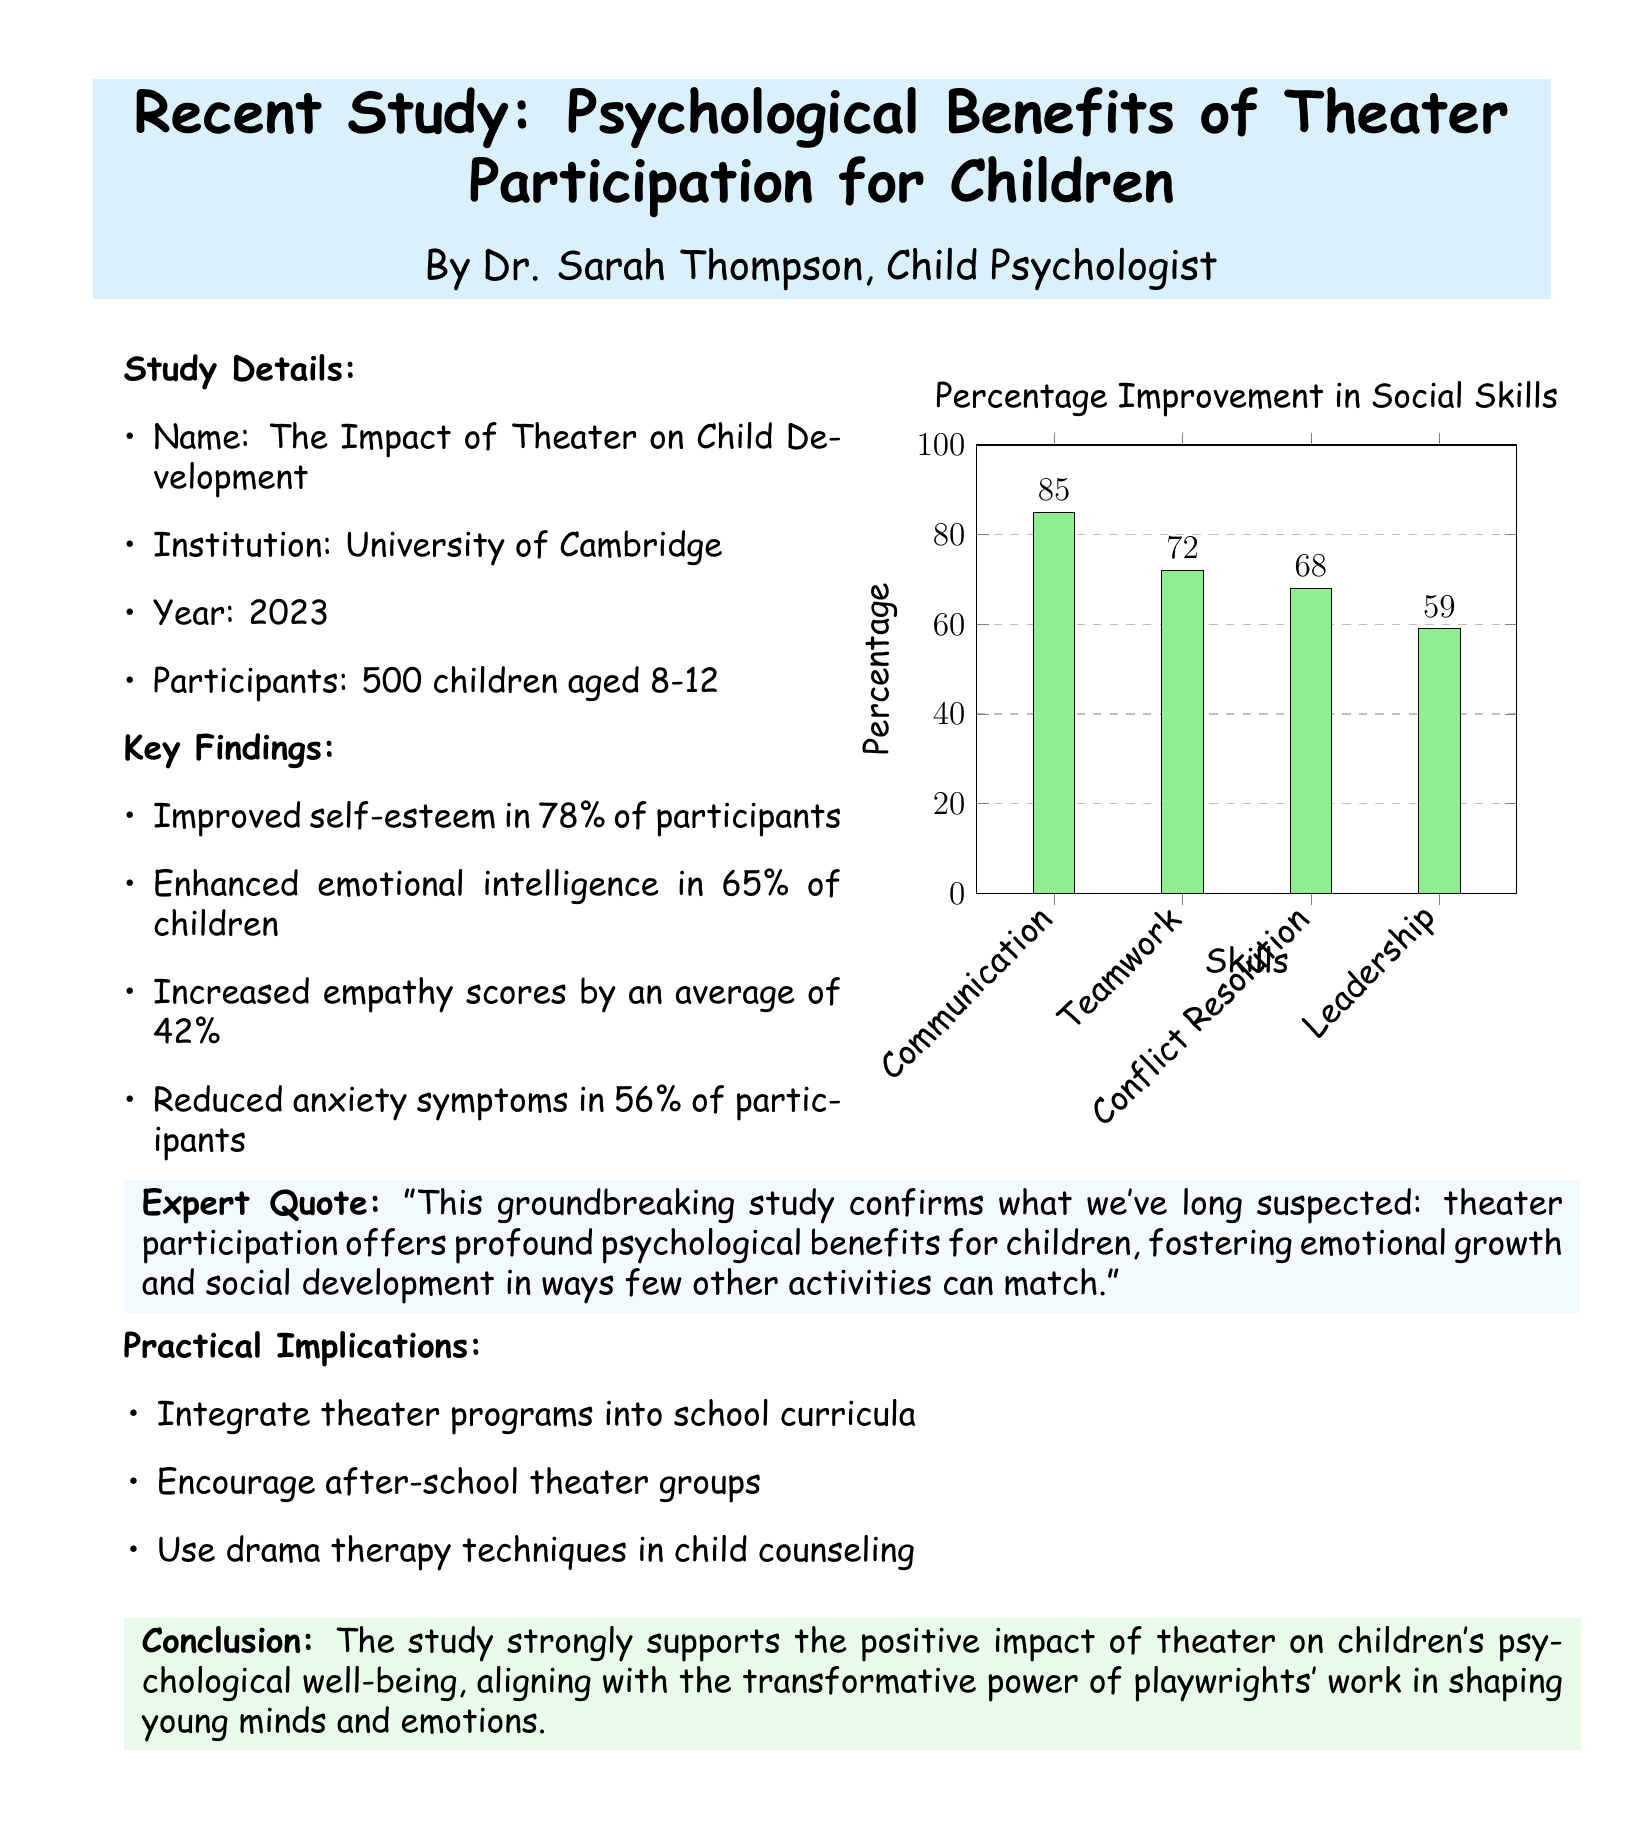What is the name of the study? The document mentions "The Impact of Theater on Child Development" as the name of the study.
Answer: The Impact of Theater on Child Development What year was the study conducted? According to the document, the study was conducted in 2023.
Answer: 2023 How many children participated in the study? The document states that there were 500 children involved in the study.
Answer: 500 What percentage of participants improved their self-esteem? The document indicates that 78% of participants saw an improvement in their self-esteem.
Answer: 78% What was the average increase in empathy scores? The document reports that empathy scores increased by an average of 42%.
Answer: 42% What is one practical implication suggested in the study? The document suggests "Integrate theater programs into school curricula" as one of the practical implications.
Answer: Integrate theater programs into school curricula Which skill showed the highest percentage improvement in social skills? According to the graph, Communication had the highest percentage improvement at 85%.
Answer: Communication What expert role does Dr. Sarah Thompson hold? The document identifies Dr. Sarah Thompson as a Child Psychologist.
Answer: Child Psychologist What color is used for the key findings box? The color used for the key findings box is childblue.
Answer: childblue 